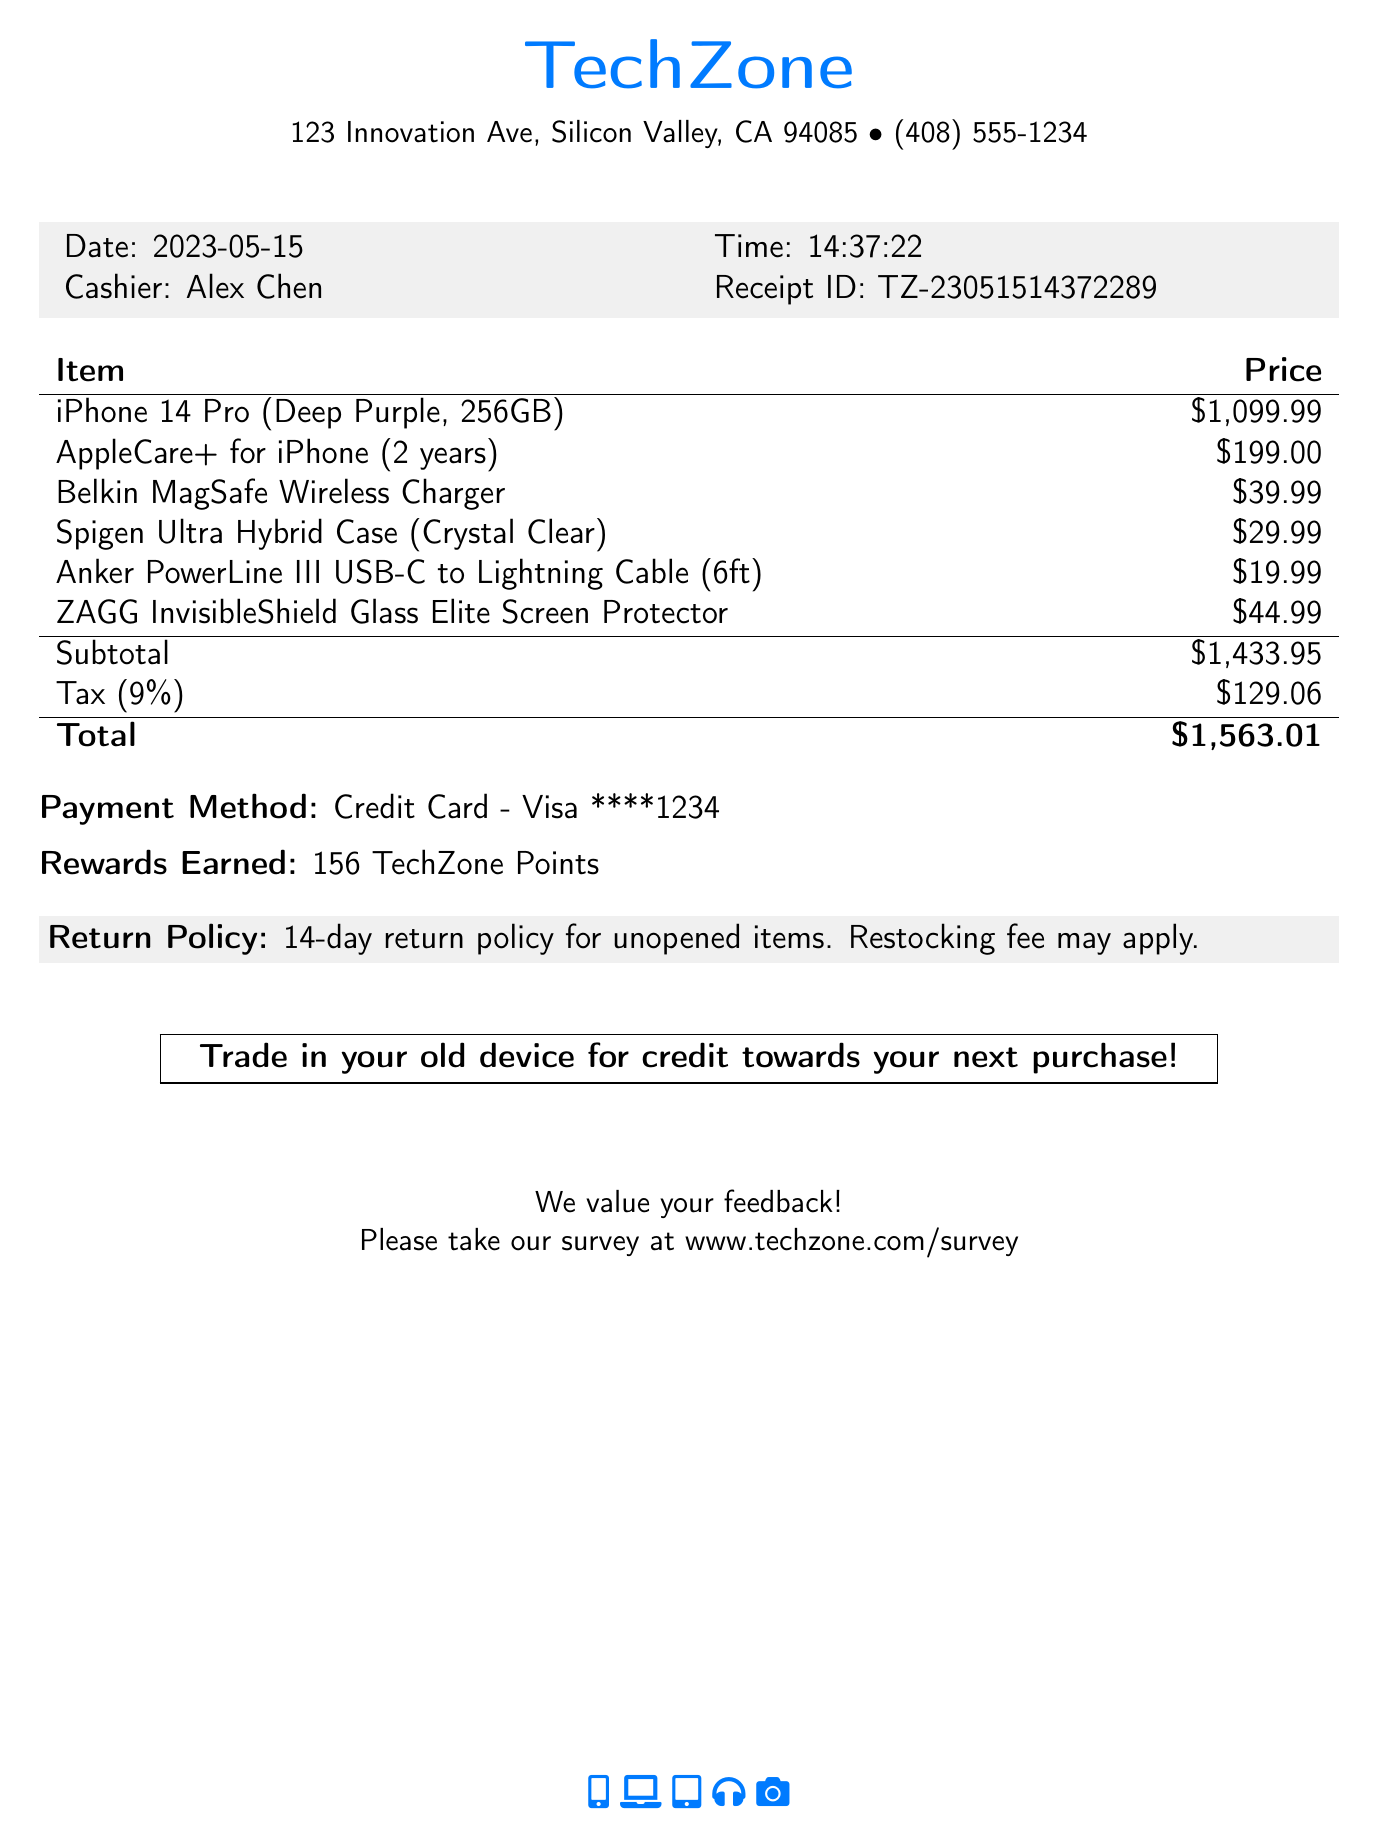What is the store name? The store name is presented at the top of the document.
Answer: TechZone What is the receipt ID? The receipt ID is listed near the cashier's name and date.
Answer: TZ-23051514372289 What was the total amount spent? The total amount is shown at the bottom of the itemized list.
Answer: $1,563.01 What is the tax amount? The tax amount is provided after the subtotal in the pricing section.
Answer: $129.06 How many TechZone Points were earned? The points earned are mentioned after the payment method.
Answer: 156 What is the duration of the warranty? The warranty duration is mentioned alongside the AppleCare+ item.
Answer: 2 years What color is the iPhone purchased? The color of the iPhone is specified in the item description.
Answer: Deep Purple What is the return policy? The return policy is outlined in the gray box near the bottom of the receipt.
Answer: 14-day return policy for unopened items. Restocking fee may apply Where can feedback be submitted? The survey link for feedback is located at the bottom of the document.
Answer: www.techzone.com/survey What accessories were purchased with the smartphone? The accessories purchased are listed in the itemized section.
Answer: Belkin MagSafe Wireless Charger, Spigen Ultra Hybrid Case, Anker PowerLine III USB-C to Lightning Cable, ZAGG InvisibleShield Glass Elite Screen Protector 